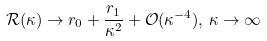<formula> <loc_0><loc_0><loc_500><loc_500>\mathcal { R } ( \kappa ) \to r _ { 0 } + \frac { r _ { 1 } } { \kappa ^ { 2 } } + \mathcal { O } ( \kappa ^ { - 4 } ) , \, \kappa \to \infty</formula> 